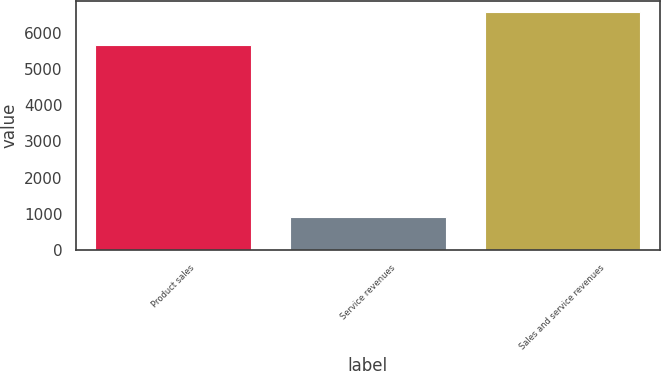Convert chart to OTSL. <chart><loc_0><loc_0><loc_500><loc_500><bar_chart><fcel>Product sales<fcel>Service revenues<fcel>Sales and service revenues<nl><fcel>5676<fcel>899<fcel>6575<nl></chart> 